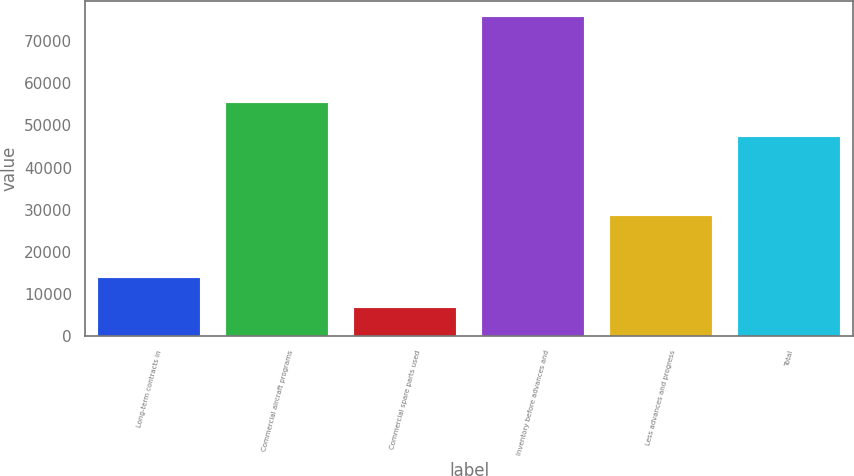Convert chart to OTSL. <chart><loc_0><loc_0><loc_500><loc_500><bar_chart><fcel>Long-term contracts in<fcel>Commercial aircraft programs<fcel>Commercial spare parts used<fcel>Inventory before advances and<fcel>Less advances and progress<fcel>Total<nl><fcel>13858<fcel>55230<fcel>6673<fcel>75761<fcel>28504<fcel>47257<nl></chart> 